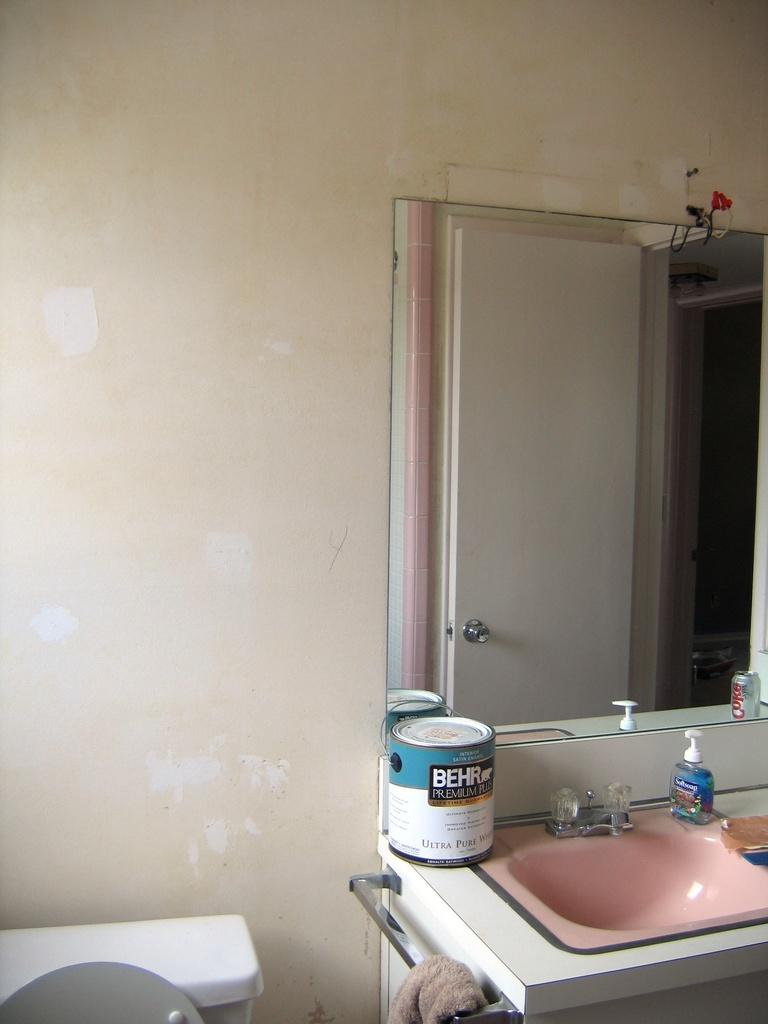What is the main fixture in the image? There is a sink in the image. What is attached to the sink? There is a tap in the image. What type of hygiene product is present in the image? There is a bottle of Dettol hand wash in the image. What other object can be seen in the image? There is a box in the image. What is used for personal grooming in the image? There is a mirror in the image. What color is the wall in the image? The wall in the image is white. Where is the bee flying in the image? There is no bee present in the image. Who is the partner of the person using the sink in the image? There is no indication of a partner or person using the sink in the image. 